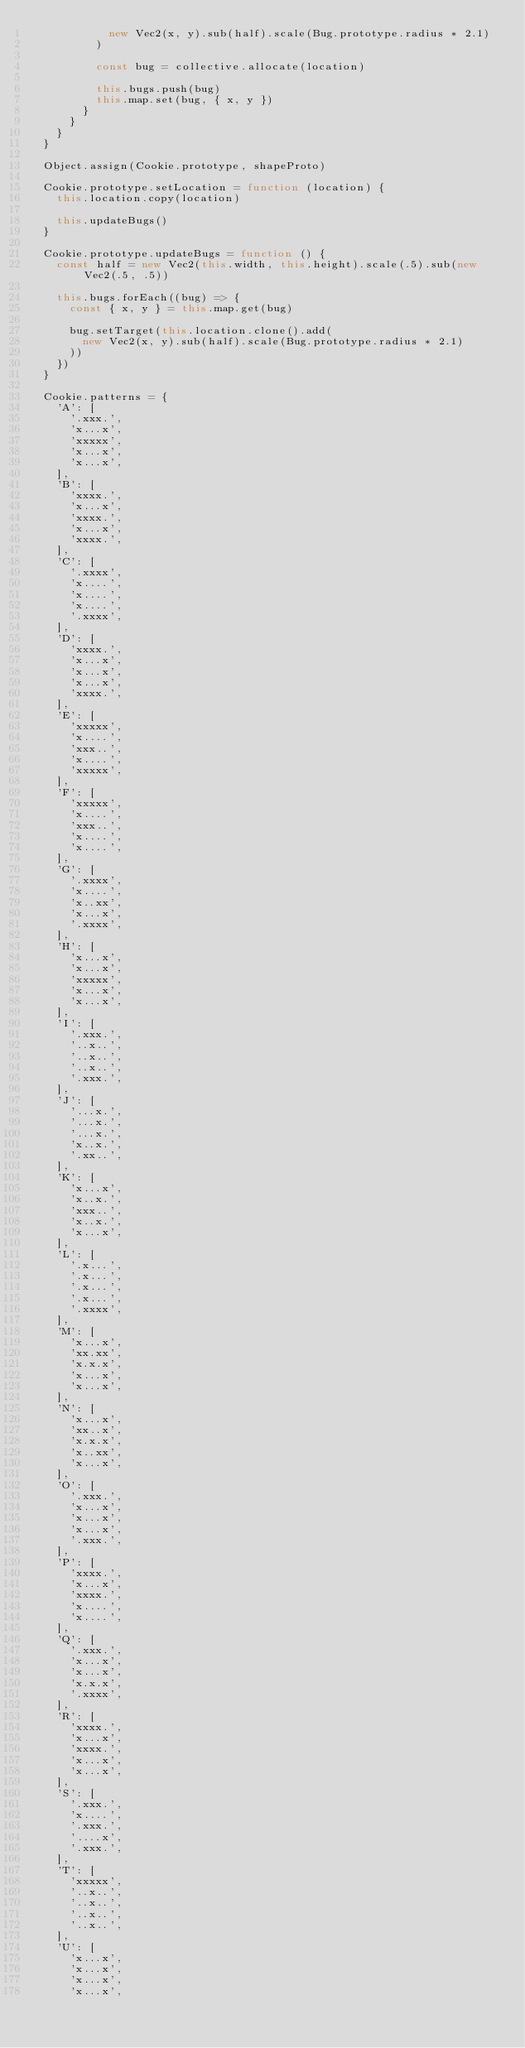Convert code to text. <code><loc_0><loc_0><loc_500><loc_500><_JavaScript_>						new Vec2(x, y).sub(half).scale(Bug.prototype.radius * 2.1)
					)

					const bug = collective.allocate(location)

					this.bugs.push(bug)
					this.map.set(bug, { x, y })
				}
			}
		}
	}

	Object.assign(Cookie.prototype, shapeProto)

	Cookie.prototype.setLocation = function (location) {
		this.location.copy(location)

		this.updateBugs()
	}

	Cookie.prototype.updateBugs = function () {
		const half = new Vec2(this.width, this.height).scale(.5).sub(new Vec2(.5, .5))

		this.bugs.forEach((bug) => {
			const { x, y } = this.map.get(bug)

			bug.setTarget(this.location.clone().add(
				new Vec2(x, y).sub(half).scale(Bug.prototype.radius * 2.1)
			))
		})
	}

	Cookie.patterns = {
		'A': [
			'.xxx.',
			'x...x',
			'xxxxx',
			'x...x',
			'x...x',
		],
		'B': [
			'xxxx.',
			'x...x',
			'xxxx.',
			'x...x',
			'xxxx.',
		],
		'C': [
			'.xxxx',
			'x....',
			'x....',
			'x....',
			'.xxxx',
		],
		'D': [
			'xxxx.',
			'x...x',
			'x...x',
			'x...x',
			'xxxx.',
		],
		'E': [
			'xxxxx',
			'x....',
			'xxx..',
			'x....',
			'xxxxx',
		],
		'F': [
			'xxxxx',
			'x....',
			'xxx..',
			'x....',
			'x....',
		],
		'G': [
			'.xxxx',
			'x....',
			'x..xx',
			'x...x',
			'.xxxx',
		],
		'H': [
			'x...x',
			'x...x',
			'xxxxx',
			'x...x',
			'x...x',
		],
		'I': [
			'.xxx.',
			'..x..',
			'..x..',
			'..x..',
			'.xxx.',
		],
		'J': [
			'...x.',
			'...x.',
			'...x.',
			'x..x.',
			'.xx..',
		],
		'K': [
			'x...x',
			'x..x.',
			'xxx..',
			'x..x.',
			'x...x',
		],
		'L': [
			'.x...',
			'.x...',
			'.x...',
			'.x...',
			'.xxxx',
		],
		'M': [
			'x...x',
			'xx.xx',
			'x.x.x',
			'x...x',
			'x...x',
		],
		'N': [
			'x...x',
			'xx..x',
			'x.x.x',
			'x..xx',
			'x...x',
		],
		'O': [
			'.xxx.',
			'x...x',
			'x...x',
			'x...x',
			'.xxx.',
		],
		'P': [
			'xxxx.',
			'x...x',
			'xxxx.',
			'x....',
			'x....',
		],
		'Q': [
			'.xxx.',
			'x...x',
			'x...x',
			'x.x.x',
			'.xxxx',
		],
		'R': [
			'xxxx.',
			'x...x',
			'xxxx.',
			'x...x',
			'x...x',
		],
		'S': [
			'.xxx.',
			'x....',
			'.xxx.',
			'....x',
			'.xxx.',
		],
		'T': [
			'xxxxx',
			'..x..',
			'..x..',
			'..x..',
			'..x..',
		],
		'U': [
			'x...x',
			'x...x',
			'x...x',
			'x...x',</code> 